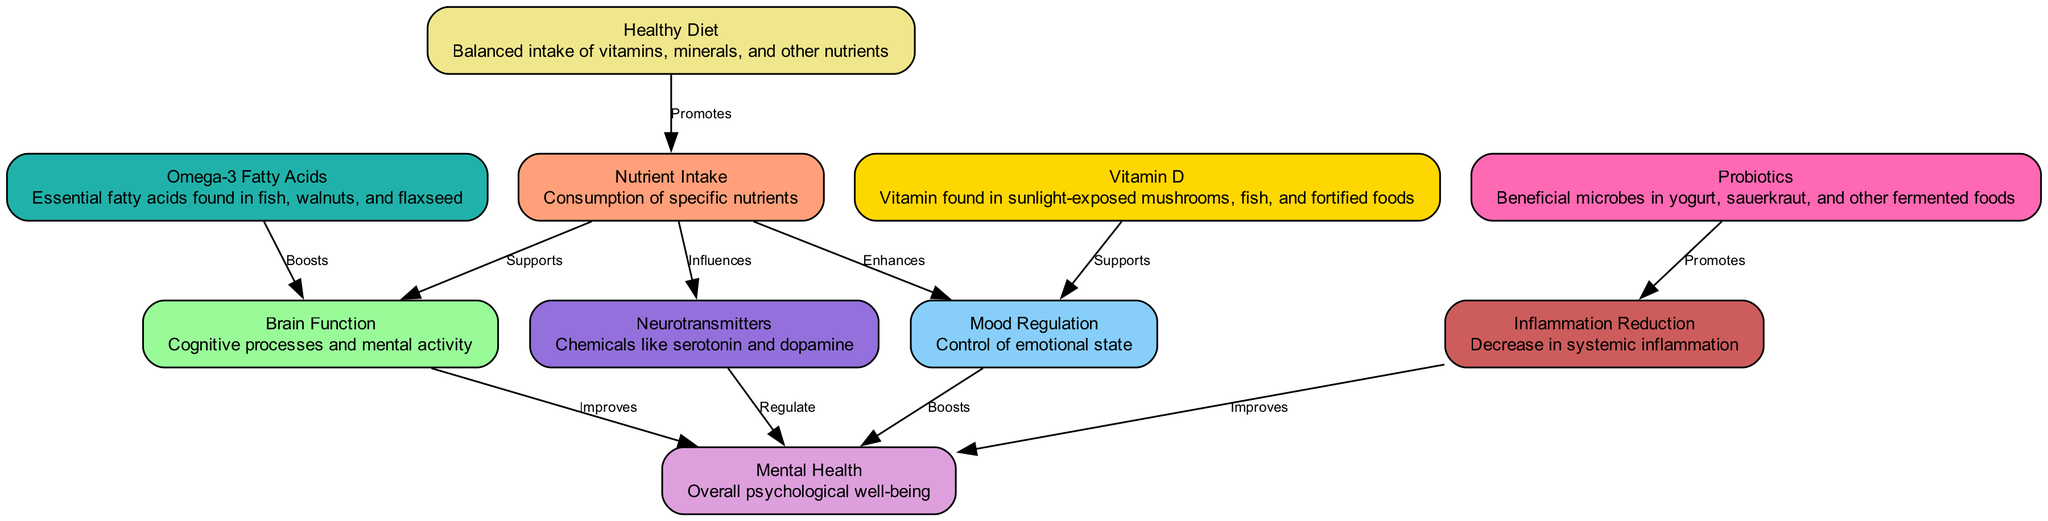What is the primary source of "Nutrient Intake"? The node labeled "Healthy Diet" is connected to "Nutrient Intake" with the edge labeled "Promotes", indicating that a healthy diet is the primary source for nutrient intake.
Answer: Healthy Diet How many nodes are present in the diagram? By counting the unique nodes listed in the data, we find ten distinct nodes defined under "nodes".
Answer: 10 Which nutrient supports "Mood Regulation"? The "Vitamin D" node has a directed edge labeled "Supports" pointing towards "Mood Regulation", showing that it plays a supportive role in regulating mood.
Answer: Vitamin D What improves "Mental Health"? "Brain Function" and "Inflammation Reduction" nodes both have edges pointing toward "Mental Health" with the labels "Improves", which indicates that both improve mental health.
Answer: Brain Function, Inflammation Reduction Which nutrient influences "Neurotransmitters"? In the diagram's edges, there is a directed edge from "Nutrient Intake" to "Neurotransmitters" labeled "Influences", indicating that nutrient intake influences neurotransmitter levels.
Answer: Nutrient Intake How does "Probiotics" relate to "Mental Health"? "Probiotics" connects indirectly to "Mental Health" through "Inflammation Reduction", which improves mental health, showing that probiotics ultimately have a positive influence on mental health.
Answer: Indirectly via Inflammation Reduction Which nutrient boosts "Brain Function"? The edge labeled "Boosts" is directed from "Omega-3 Fatty Acids" to "Brain Function", indicating that omega-3 fatty acids act to boost brain function.
Answer: Omega-3 Fatty Acids What is the relationship between "Mood Regulation" and "Mental Health"? The direct edge labeled "Boosts" from "Mood Regulation" to "Mental Health" shows that mood regulation has a boosting effect on overall mental health.
Answer: Boosts What role does "Neurotransmitters" play in the diagram? The node "Neurotransmitters" directly regulates "Mental Health", meaning it has a crucial role in determining psychological well-being.
Answer: Regulate 